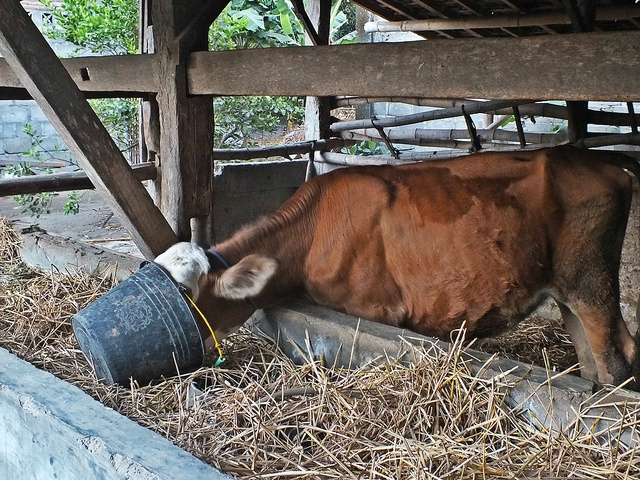Describe the objects in this image and their specific colors. I can see a cow in black, maroon, and brown tones in this image. 